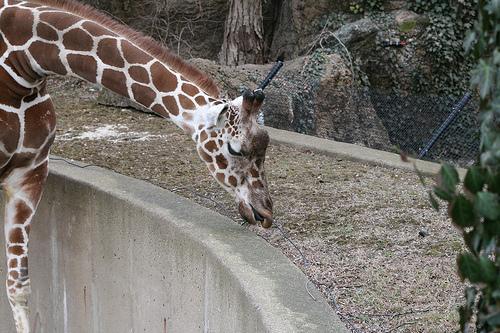How many giraffes are in the pic?
Give a very brief answer. 1. How many trees are there?
Give a very brief answer. 1. 